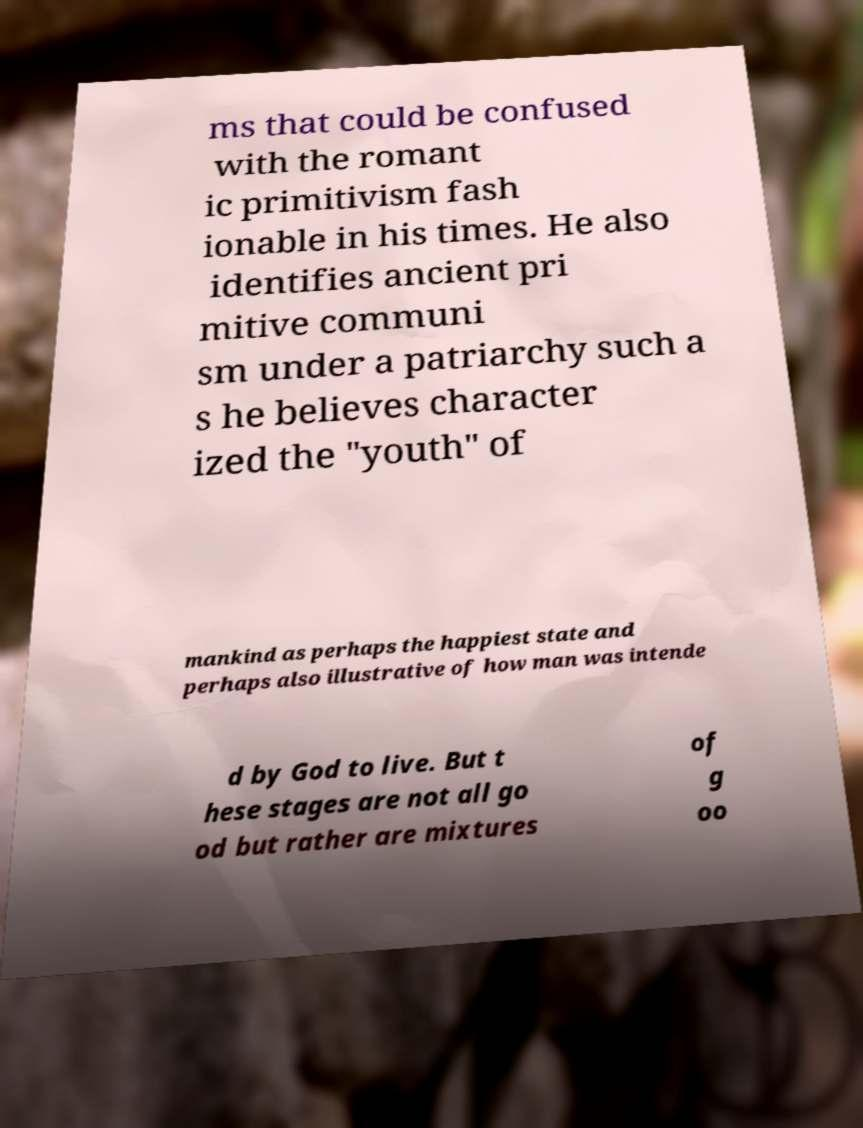Please identify and transcribe the text found in this image. ms that could be confused with the romant ic primitivism fash ionable in his times. He also identifies ancient pri mitive communi sm under a patriarchy such a s he believes character ized the "youth" of mankind as perhaps the happiest state and perhaps also illustrative of how man was intende d by God to live. But t hese stages are not all go od but rather are mixtures of g oo 